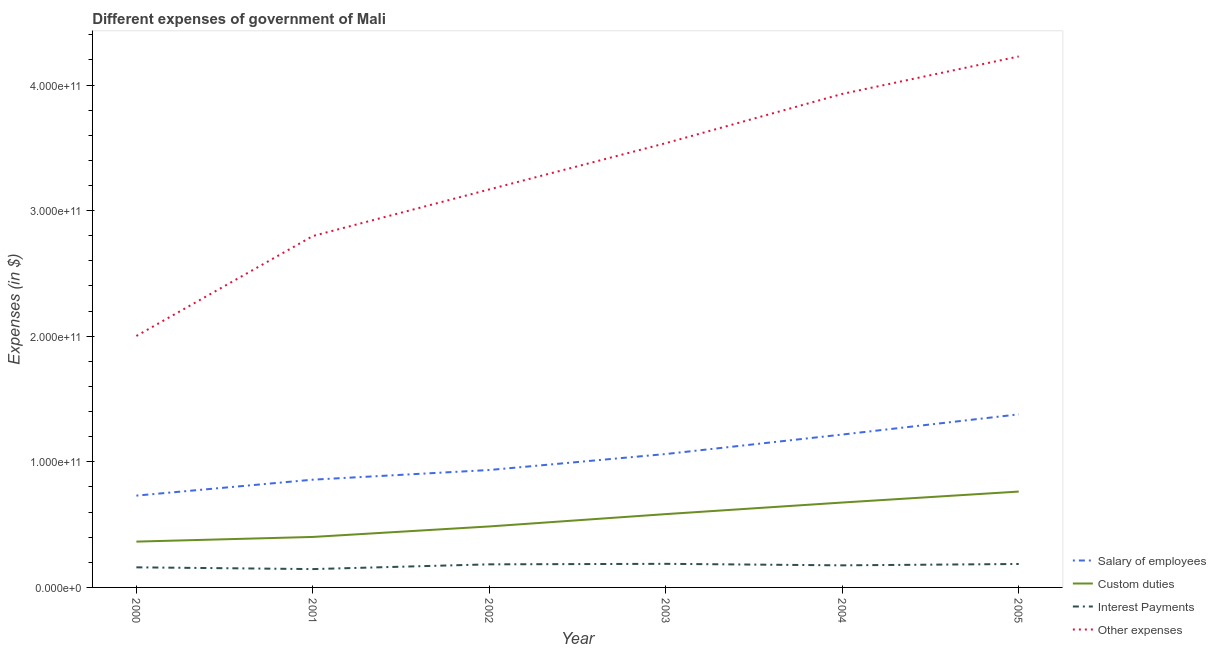Does the line corresponding to amount spent on other expenses intersect with the line corresponding to amount spent on salary of employees?
Your response must be concise. No. What is the amount spent on salary of employees in 2003?
Your answer should be compact. 1.06e+11. Across all years, what is the maximum amount spent on interest payments?
Provide a short and direct response. 1.88e+1. Across all years, what is the minimum amount spent on salary of employees?
Provide a succinct answer. 7.31e+1. In which year was the amount spent on interest payments minimum?
Your answer should be very brief. 2001. What is the total amount spent on interest payments in the graph?
Give a very brief answer. 1.04e+11. What is the difference between the amount spent on other expenses in 2004 and that in 2005?
Provide a succinct answer. -2.98e+1. What is the difference between the amount spent on interest payments in 2004 and the amount spent on custom duties in 2001?
Keep it short and to the point. -2.26e+1. What is the average amount spent on salary of employees per year?
Provide a short and direct response. 1.03e+11. In the year 2004, what is the difference between the amount spent on interest payments and amount spent on salary of employees?
Provide a short and direct response. -1.04e+11. In how many years, is the amount spent on custom duties greater than 220000000000 $?
Your answer should be compact. 0. What is the ratio of the amount spent on salary of employees in 2001 to that in 2004?
Provide a short and direct response. 0.7. Is the difference between the amount spent on custom duties in 2002 and 2003 greater than the difference between the amount spent on other expenses in 2002 and 2003?
Your answer should be very brief. Yes. What is the difference between the highest and the second highest amount spent on salary of employees?
Provide a short and direct response. 1.61e+1. What is the difference between the highest and the lowest amount spent on other expenses?
Your response must be concise. 2.23e+11. Is it the case that in every year, the sum of the amount spent on interest payments and amount spent on other expenses is greater than the sum of amount spent on salary of employees and amount spent on custom duties?
Keep it short and to the point. No. What is the difference between two consecutive major ticks on the Y-axis?
Your response must be concise. 1.00e+11. Does the graph contain grids?
Make the answer very short. No. How many legend labels are there?
Keep it short and to the point. 4. What is the title of the graph?
Offer a very short reply. Different expenses of government of Mali. Does "Secondary general" appear as one of the legend labels in the graph?
Provide a succinct answer. No. What is the label or title of the X-axis?
Provide a short and direct response. Year. What is the label or title of the Y-axis?
Keep it short and to the point. Expenses (in $). What is the Expenses (in $) of Salary of employees in 2000?
Provide a succinct answer. 7.31e+1. What is the Expenses (in $) of Custom duties in 2000?
Provide a short and direct response. 3.65e+1. What is the Expenses (in $) of Interest Payments in 2000?
Provide a succinct answer. 1.60e+1. What is the Expenses (in $) in Other expenses in 2000?
Provide a succinct answer. 2.00e+11. What is the Expenses (in $) of Salary of employees in 2001?
Offer a terse response. 8.58e+1. What is the Expenses (in $) in Custom duties in 2001?
Provide a short and direct response. 4.02e+1. What is the Expenses (in $) of Interest Payments in 2001?
Your answer should be compact. 1.46e+1. What is the Expenses (in $) of Other expenses in 2001?
Give a very brief answer. 2.80e+11. What is the Expenses (in $) of Salary of employees in 2002?
Ensure brevity in your answer.  9.35e+1. What is the Expenses (in $) in Custom duties in 2002?
Your answer should be very brief. 4.86e+1. What is the Expenses (in $) of Interest Payments in 2002?
Your answer should be very brief. 1.84e+1. What is the Expenses (in $) in Other expenses in 2002?
Your answer should be very brief. 3.17e+11. What is the Expenses (in $) in Salary of employees in 2003?
Provide a short and direct response. 1.06e+11. What is the Expenses (in $) of Custom duties in 2003?
Provide a succinct answer. 5.84e+1. What is the Expenses (in $) in Interest Payments in 2003?
Your answer should be very brief. 1.88e+1. What is the Expenses (in $) of Other expenses in 2003?
Offer a terse response. 3.54e+11. What is the Expenses (in $) in Salary of employees in 2004?
Your answer should be compact. 1.22e+11. What is the Expenses (in $) in Custom duties in 2004?
Your response must be concise. 6.76e+1. What is the Expenses (in $) of Interest Payments in 2004?
Your answer should be very brief. 1.76e+1. What is the Expenses (in $) in Other expenses in 2004?
Make the answer very short. 3.93e+11. What is the Expenses (in $) in Salary of employees in 2005?
Offer a terse response. 1.38e+11. What is the Expenses (in $) in Custom duties in 2005?
Your answer should be very brief. 7.63e+1. What is the Expenses (in $) of Interest Payments in 2005?
Your answer should be very brief. 1.87e+1. What is the Expenses (in $) of Other expenses in 2005?
Give a very brief answer. 4.23e+11. Across all years, what is the maximum Expenses (in $) in Salary of employees?
Ensure brevity in your answer.  1.38e+11. Across all years, what is the maximum Expenses (in $) of Custom duties?
Provide a short and direct response. 7.63e+1. Across all years, what is the maximum Expenses (in $) of Interest Payments?
Provide a succinct answer. 1.88e+1. Across all years, what is the maximum Expenses (in $) in Other expenses?
Provide a short and direct response. 4.23e+11. Across all years, what is the minimum Expenses (in $) of Salary of employees?
Keep it short and to the point. 7.31e+1. Across all years, what is the minimum Expenses (in $) of Custom duties?
Keep it short and to the point. 3.65e+1. Across all years, what is the minimum Expenses (in $) in Interest Payments?
Ensure brevity in your answer.  1.46e+1. Across all years, what is the minimum Expenses (in $) in Other expenses?
Offer a very short reply. 2.00e+11. What is the total Expenses (in $) of Salary of employees in the graph?
Provide a short and direct response. 6.18e+11. What is the total Expenses (in $) of Custom duties in the graph?
Provide a short and direct response. 3.28e+11. What is the total Expenses (in $) in Interest Payments in the graph?
Keep it short and to the point. 1.04e+11. What is the total Expenses (in $) of Other expenses in the graph?
Give a very brief answer. 1.97e+12. What is the difference between the Expenses (in $) in Salary of employees in 2000 and that in 2001?
Give a very brief answer. -1.27e+1. What is the difference between the Expenses (in $) of Custom duties in 2000 and that in 2001?
Provide a succinct answer. -3.72e+09. What is the difference between the Expenses (in $) of Interest Payments in 2000 and that in 2001?
Keep it short and to the point. 1.40e+09. What is the difference between the Expenses (in $) in Other expenses in 2000 and that in 2001?
Your response must be concise. -7.96e+1. What is the difference between the Expenses (in $) of Salary of employees in 2000 and that in 2002?
Keep it short and to the point. -2.04e+1. What is the difference between the Expenses (in $) of Custom duties in 2000 and that in 2002?
Offer a very short reply. -1.21e+1. What is the difference between the Expenses (in $) in Interest Payments in 2000 and that in 2002?
Give a very brief answer. -2.38e+09. What is the difference between the Expenses (in $) of Other expenses in 2000 and that in 2002?
Make the answer very short. -1.17e+11. What is the difference between the Expenses (in $) of Salary of employees in 2000 and that in 2003?
Keep it short and to the point. -3.31e+1. What is the difference between the Expenses (in $) in Custom duties in 2000 and that in 2003?
Offer a terse response. -2.19e+1. What is the difference between the Expenses (in $) of Interest Payments in 2000 and that in 2003?
Offer a very short reply. -2.79e+09. What is the difference between the Expenses (in $) of Other expenses in 2000 and that in 2003?
Provide a succinct answer. -1.54e+11. What is the difference between the Expenses (in $) in Salary of employees in 2000 and that in 2004?
Give a very brief answer. -4.86e+1. What is the difference between the Expenses (in $) of Custom duties in 2000 and that in 2004?
Offer a terse response. -3.11e+1. What is the difference between the Expenses (in $) of Interest Payments in 2000 and that in 2004?
Keep it short and to the point. -1.58e+09. What is the difference between the Expenses (in $) in Other expenses in 2000 and that in 2004?
Give a very brief answer. -1.93e+11. What is the difference between the Expenses (in $) in Salary of employees in 2000 and that in 2005?
Your answer should be very brief. -6.47e+1. What is the difference between the Expenses (in $) of Custom duties in 2000 and that in 2005?
Your answer should be compact. -3.98e+1. What is the difference between the Expenses (in $) in Interest Payments in 2000 and that in 2005?
Provide a succinct answer. -2.66e+09. What is the difference between the Expenses (in $) in Other expenses in 2000 and that in 2005?
Offer a very short reply. -2.23e+11. What is the difference between the Expenses (in $) of Salary of employees in 2001 and that in 2002?
Keep it short and to the point. -7.70e+09. What is the difference between the Expenses (in $) in Custom duties in 2001 and that in 2002?
Give a very brief answer. -8.35e+09. What is the difference between the Expenses (in $) of Interest Payments in 2001 and that in 2002?
Your answer should be very brief. -3.78e+09. What is the difference between the Expenses (in $) of Other expenses in 2001 and that in 2002?
Offer a terse response. -3.71e+1. What is the difference between the Expenses (in $) in Salary of employees in 2001 and that in 2003?
Give a very brief answer. -2.04e+1. What is the difference between the Expenses (in $) of Custom duties in 2001 and that in 2003?
Give a very brief answer. -1.82e+1. What is the difference between the Expenses (in $) of Interest Payments in 2001 and that in 2003?
Offer a terse response. -4.19e+09. What is the difference between the Expenses (in $) of Other expenses in 2001 and that in 2003?
Your answer should be compact. -7.39e+1. What is the difference between the Expenses (in $) in Salary of employees in 2001 and that in 2004?
Offer a very short reply. -3.59e+1. What is the difference between the Expenses (in $) in Custom duties in 2001 and that in 2004?
Offer a terse response. -2.74e+1. What is the difference between the Expenses (in $) of Interest Payments in 2001 and that in 2004?
Keep it short and to the point. -2.98e+09. What is the difference between the Expenses (in $) of Other expenses in 2001 and that in 2004?
Make the answer very short. -1.13e+11. What is the difference between the Expenses (in $) in Salary of employees in 2001 and that in 2005?
Give a very brief answer. -5.20e+1. What is the difference between the Expenses (in $) in Custom duties in 2001 and that in 2005?
Offer a terse response. -3.61e+1. What is the difference between the Expenses (in $) of Interest Payments in 2001 and that in 2005?
Your answer should be compact. -4.06e+09. What is the difference between the Expenses (in $) in Other expenses in 2001 and that in 2005?
Provide a succinct answer. -1.43e+11. What is the difference between the Expenses (in $) of Salary of employees in 2002 and that in 2003?
Make the answer very short. -1.27e+1. What is the difference between the Expenses (in $) in Custom duties in 2002 and that in 2003?
Ensure brevity in your answer.  -9.82e+09. What is the difference between the Expenses (in $) in Interest Payments in 2002 and that in 2003?
Offer a terse response. -4.08e+08. What is the difference between the Expenses (in $) of Other expenses in 2002 and that in 2003?
Keep it short and to the point. -3.68e+1. What is the difference between the Expenses (in $) of Salary of employees in 2002 and that in 2004?
Your answer should be very brief. -2.82e+1. What is the difference between the Expenses (in $) of Custom duties in 2002 and that in 2004?
Provide a succinct answer. -1.90e+1. What is the difference between the Expenses (in $) of Interest Payments in 2002 and that in 2004?
Ensure brevity in your answer.  8.02e+08. What is the difference between the Expenses (in $) of Other expenses in 2002 and that in 2004?
Provide a short and direct response. -7.60e+1. What is the difference between the Expenses (in $) in Salary of employees in 2002 and that in 2005?
Provide a succinct answer. -4.43e+1. What is the difference between the Expenses (in $) of Custom duties in 2002 and that in 2005?
Give a very brief answer. -2.78e+1. What is the difference between the Expenses (in $) of Interest Payments in 2002 and that in 2005?
Offer a very short reply. -2.80e+08. What is the difference between the Expenses (in $) of Other expenses in 2002 and that in 2005?
Provide a succinct answer. -1.06e+11. What is the difference between the Expenses (in $) of Salary of employees in 2003 and that in 2004?
Provide a succinct answer. -1.55e+1. What is the difference between the Expenses (in $) in Custom duties in 2003 and that in 2004?
Your answer should be very brief. -9.22e+09. What is the difference between the Expenses (in $) of Interest Payments in 2003 and that in 2004?
Offer a very short reply. 1.21e+09. What is the difference between the Expenses (in $) of Other expenses in 2003 and that in 2004?
Provide a succinct answer. -3.92e+1. What is the difference between the Expenses (in $) of Salary of employees in 2003 and that in 2005?
Provide a succinct answer. -3.16e+1. What is the difference between the Expenses (in $) in Custom duties in 2003 and that in 2005?
Your answer should be very brief. -1.79e+1. What is the difference between the Expenses (in $) of Interest Payments in 2003 and that in 2005?
Give a very brief answer. 1.27e+08. What is the difference between the Expenses (in $) of Other expenses in 2003 and that in 2005?
Your answer should be compact. -6.90e+1. What is the difference between the Expenses (in $) in Salary of employees in 2004 and that in 2005?
Provide a succinct answer. -1.61e+1. What is the difference between the Expenses (in $) of Custom duties in 2004 and that in 2005?
Ensure brevity in your answer.  -8.73e+09. What is the difference between the Expenses (in $) of Interest Payments in 2004 and that in 2005?
Your answer should be compact. -1.08e+09. What is the difference between the Expenses (in $) of Other expenses in 2004 and that in 2005?
Make the answer very short. -2.98e+1. What is the difference between the Expenses (in $) of Salary of employees in 2000 and the Expenses (in $) of Custom duties in 2001?
Offer a very short reply. 3.29e+1. What is the difference between the Expenses (in $) in Salary of employees in 2000 and the Expenses (in $) in Interest Payments in 2001?
Provide a succinct answer. 5.85e+1. What is the difference between the Expenses (in $) of Salary of employees in 2000 and the Expenses (in $) of Other expenses in 2001?
Your answer should be very brief. -2.07e+11. What is the difference between the Expenses (in $) of Custom duties in 2000 and the Expenses (in $) of Interest Payments in 2001?
Ensure brevity in your answer.  2.19e+1. What is the difference between the Expenses (in $) in Custom duties in 2000 and the Expenses (in $) in Other expenses in 2001?
Offer a very short reply. -2.43e+11. What is the difference between the Expenses (in $) of Interest Payments in 2000 and the Expenses (in $) of Other expenses in 2001?
Make the answer very short. -2.64e+11. What is the difference between the Expenses (in $) of Salary of employees in 2000 and the Expenses (in $) of Custom duties in 2002?
Make the answer very short. 2.45e+1. What is the difference between the Expenses (in $) of Salary of employees in 2000 and the Expenses (in $) of Interest Payments in 2002?
Your response must be concise. 5.47e+1. What is the difference between the Expenses (in $) in Salary of employees in 2000 and the Expenses (in $) in Other expenses in 2002?
Your answer should be very brief. -2.44e+11. What is the difference between the Expenses (in $) in Custom duties in 2000 and the Expenses (in $) in Interest Payments in 2002?
Offer a terse response. 1.81e+1. What is the difference between the Expenses (in $) in Custom duties in 2000 and the Expenses (in $) in Other expenses in 2002?
Provide a succinct answer. -2.80e+11. What is the difference between the Expenses (in $) in Interest Payments in 2000 and the Expenses (in $) in Other expenses in 2002?
Your response must be concise. -3.01e+11. What is the difference between the Expenses (in $) in Salary of employees in 2000 and the Expenses (in $) in Custom duties in 2003?
Provide a short and direct response. 1.47e+1. What is the difference between the Expenses (in $) of Salary of employees in 2000 and the Expenses (in $) of Interest Payments in 2003?
Give a very brief answer. 5.43e+1. What is the difference between the Expenses (in $) of Salary of employees in 2000 and the Expenses (in $) of Other expenses in 2003?
Provide a short and direct response. -2.81e+11. What is the difference between the Expenses (in $) of Custom duties in 2000 and the Expenses (in $) of Interest Payments in 2003?
Give a very brief answer. 1.77e+1. What is the difference between the Expenses (in $) in Custom duties in 2000 and the Expenses (in $) in Other expenses in 2003?
Keep it short and to the point. -3.17e+11. What is the difference between the Expenses (in $) of Interest Payments in 2000 and the Expenses (in $) of Other expenses in 2003?
Provide a short and direct response. -3.38e+11. What is the difference between the Expenses (in $) of Salary of employees in 2000 and the Expenses (in $) of Custom duties in 2004?
Ensure brevity in your answer.  5.51e+09. What is the difference between the Expenses (in $) in Salary of employees in 2000 and the Expenses (in $) in Interest Payments in 2004?
Make the answer very short. 5.55e+1. What is the difference between the Expenses (in $) in Salary of employees in 2000 and the Expenses (in $) in Other expenses in 2004?
Provide a short and direct response. -3.20e+11. What is the difference between the Expenses (in $) in Custom duties in 2000 and the Expenses (in $) in Interest Payments in 2004?
Keep it short and to the point. 1.89e+1. What is the difference between the Expenses (in $) of Custom duties in 2000 and the Expenses (in $) of Other expenses in 2004?
Keep it short and to the point. -3.56e+11. What is the difference between the Expenses (in $) of Interest Payments in 2000 and the Expenses (in $) of Other expenses in 2004?
Provide a short and direct response. -3.77e+11. What is the difference between the Expenses (in $) in Salary of employees in 2000 and the Expenses (in $) in Custom duties in 2005?
Make the answer very short. -3.22e+09. What is the difference between the Expenses (in $) of Salary of employees in 2000 and the Expenses (in $) of Interest Payments in 2005?
Provide a short and direct response. 5.44e+1. What is the difference between the Expenses (in $) in Salary of employees in 2000 and the Expenses (in $) in Other expenses in 2005?
Give a very brief answer. -3.50e+11. What is the difference between the Expenses (in $) in Custom duties in 2000 and the Expenses (in $) in Interest Payments in 2005?
Your answer should be very brief. 1.78e+1. What is the difference between the Expenses (in $) in Custom duties in 2000 and the Expenses (in $) in Other expenses in 2005?
Offer a very short reply. -3.86e+11. What is the difference between the Expenses (in $) in Interest Payments in 2000 and the Expenses (in $) in Other expenses in 2005?
Your answer should be compact. -4.07e+11. What is the difference between the Expenses (in $) of Salary of employees in 2001 and the Expenses (in $) of Custom duties in 2002?
Your answer should be very brief. 3.72e+1. What is the difference between the Expenses (in $) in Salary of employees in 2001 and the Expenses (in $) in Interest Payments in 2002?
Your answer should be compact. 6.74e+1. What is the difference between the Expenses (in $) of Salary of employees in 2001 and the Expenses (in $) of Other expenses in 2002?
Offer a very short reply. -2.31e+11. What is the difference between the Expenses (in $) of Custom duties in 2001 and the Expenses (in $) of Interest Payments in 2002?
Your answer should be compact. 2.18e+1. What is the difference between the Expenses (in $) in Custom duties in 2001 and the Expenses (in $) in Other expenses in 2002?
Your answer should be very brief. -2.77e+11. What is the difference between the Expenses (in $) in Interest Payments in 2001 and the Expenses (in $) in Other expenses in 2002?
Keep it short and to the point. -3.02e+11. What is the difference between the Expenses (in $) in Salary of employees in 2001 and the Expenses (in $) in Custom duties in 2003?
Give a very brief answer. 2.74e+1. What is the difference between the Expenses (in $) of Salary of employees in 2001 and the Expenses (in $) of Interest Payments in 2003?
Make the answer very short. 6.70e+1. What is the difference between the Expenses (in $) in Salary of employees in 2001 and the Expenses (in $) in Other expenses in 2003?
Your answer should be compact. -2.68e+11. What is the difference between the Expenses (in $) of Custom duties in 2001 and the Expenses (in $) of Interest Payments in 2003?
Offer a very short reply. 2.14e+1. What is the difference between the Expenses (in $) of Custom duties in 2001 and the Expenses (in $) of Other expenses in 2003?
Offer a terse response. -3.14e+11. What is the difference between the Expenses (in $) of Interest Payments in 2001 and the Expenses (in $) of Other expenses in 2003?
Your answer should be very brief. -3.39e+11. What is the difference between the Expenses (in $) of Salary of employees in 2001 and the Expenses (in $) of Custom duties in 2004?
Offer a very short reply. 1.82e+1. What is the difference between the Expenses (in $) in Salary of employees in 2001 and the Expenses (in $) in Interest Payments in 2004?
Your answer should be very brief. 6.82e+1. What is the difference between the Expenses (in $) of Salary of employees in 2001 and the Expenses (in $) of Other expenses in 2004?
Your answer should be compact. -3.07e+11. What is the difference between the Expenses (in $) of Custom duties in 2001 and the Expenses (in $) of Interest Payments in 2004?
Make the answer very short. 2.26e+1. What is the difference between the Expenses (in $) in Custom duties in 2001 and the Expenses (in $) in Other expenses in 2004?
Give a very brief answer. -3.53e+11. What is the difference between the Expenses (in $) in Interest Payments in 2001 and the Expenses (in $) in Other expenses in 2004?
Ensure brevity in your answer.  -3.78e+11. What is the difference between the Expenses (in $) in Salary of employees in 2001 and the Expenses (in $) in Custom duties in 2005?
Your response must be concise. 9.47e+09. What is the difference between the Expenses (in $) in Salary of employees in 2001 and the Expenses (in $) in Interest Payments in 2005?
Offer a terse response. 6.71e+1. What is the difference between the Expenses (in $) of Salary of employees in 2001 and the Expenses (in $) of Other expenses in 2005?
Your response must be concise. -3.37e+11. What is the difference between the Expenses (in $) of Custom duties in 2001 and the Expenses (in $) of Interest Payments in 2005?
Offer a terse response. 2.15e+1. What is the difference between the Expenses (in $) of Custom duties in 2001 and the Expenses (in $) of Other expenses in 2005?
Your answer should be very brief. -3.83e+11. What is the difference between the Expenses (in $) of Interest Payments in 2001 and the Expenses (in $) of Other expenses in 2005?
Your response must be concise. -4.08e+11. What is the difference between the Expenses (in $) in Salary of employees in 2002 and the Expenses (in $) in Custom duties in 2003?
Keep it short and to the point. 3.51e+1. What is the difference between the Expenses (in $) of Salary of employees in 2002 and the Expenses (in $) of Interest Payments in 2003?
Make the answer very short. 7.47e+1. What is the difference between the Expenses (in $) of Salary of employees in 2002 and the Expenses (in $) of Other expenses in 2003?
Keep it short and to the point. -2.60e+11. What is the difference between the Expenses (in $) of Custom duties in 2002 and the Expenses (in $) of Interest Payments in 2003?
Your answer should be very brief. 2.98e+1. What is the difference between the Expenses (in $) of Custom duties in 2002 and the Expenses (in $) of Other expenses in 2003?
Your answer should be very brief. -3.05e+11. What is the difference between the Expenses (in $) of Interest Payments in 2002 and the Expenses (in $) of Other expenses in 2003?
Your response must be concise. -3.35e+11. What is the difference between the Expenses (in $) in Salary of employees in 2002 and the Expenses (in $) in Custom duties in 2004?
Keep it short and to the point. 2.59e+1. What is the difference between the Expenses (in $) of Salary of employees in 2002 and the Expenses (in $) of Interest Payments in 2004?
Ensure brevity in your answer.  7.59e+1. What is the difference between the Expenses (in $) of Salary of employees in 2002 and the Expenses (in $) of Other expenses in 2004?
Offer a very short reply. -2.99e+11. What is the difference between the Expenses (in $) in Custom duties in 2002 and the Expenses (in $) in Interest Payments in 2004?
Your answer should be compact. 3.10e+1. What is the difference between the Expenses (in $) of Custom duties in 2002 and the Expenses (in $) of Other expenses in 2004?
Your answer should be compact. -3.44e+11. What is the difference between the Expenses (in $) in Interest Payments in 2002 and the Expenses (in $) in Other expenses in 2004?
Your answer should be compact. -3.75e+11. What is the difference between the Expenses (in $) of Salary of employees in 2002 and the Expenses (in $) of Custom duties in 2005?
Offer a very short reply. 1.72e+1. What is the difference between the Expenses (in $) in Salary of employees in 2002 and the Expenses (in $) in Interest Payments in 2005?
Your response must be concise. 7.48e+1. What is the difference between the Expenses (in $) of Salary of employees in 2002 and the Expenses (in $) of Other expenses in 2005?
Provide a short and direct response. -3.29e+11. What is the difference between the Expenses (in $) of Custom duties in 2002 and the Expenses (in $) of Interest Payments in 2005?
Your answer should be compact. 2.99e+1. What is the difference between the Expenses (in $) in Custom duties in 2002 and the Expenses (in $) in Other expenses in 2005?
Make the answer very short. -3.74e+11. What is the difference between the Expenses (in $) of Interest Payments in 2002 and the Expenses (in $) of Other expenses in 2005?
Your response must be concise. -4.04e+11. What is the difference between the Expenses (in $) in Salary of employees in 2003 and the Expenses (in $) in Custom duties in 2004?
Your response must be concise. 3.86e+1. What is the difference between the Expenses (in $) in Salary of employees in 2003 and the Expenses (in $) in Interest Payments in 2004?
Offer a very short reply. 8.86e+1. What is the difference between the Expenses (in $) of Salary of employees in 2003 and the Expenses (in $) of Other expenses in 2004?
Give a very brief answer. -2.87e+11. What is the difference between the Expenses (in $) of Custom duties in 2003 and the Expenses (in $) of Interest Payments in 2004?
Provide a succinct answer. 4.08e+1. What is the difference between the Expenses (in $) in Custom duties in 2003 and the Expenses (in $) in Other expenses in 2004?
Offer a very short reply. -3.35e+11. What is the difference between the Expenses (in $) in Interest Payments in 2003 and the Expenses (in $) in Other expenses in 2004?
Your answer should be very brief. -3.74e+11. What is the difference between the Expenses (in $) in Salary of employees in 2003 and the Expenses (in $) in Custom duties in 2005?
Give a very brief answer. 2.99e+1. What is the difference between the Expenses (in $) in Salary of employees in 2003 and the Expenses (in $) in Interest Payments in 2005?
Provide a short and direct response. 8.75e+1. What is the difference between the Expenses (in $) in Salary of employees in 2003 and the Expenses (in $) in Other expenses in 2005?
Keep it short and to the point. -3.17e+11. What is the difference between the Expenses (in $) of Custom duties in 2003 and the Expenses (in $) of Interest Payments in 2005?
Your answer should be very brief. 3.97e+1. What is the difference between the Expenses (in $) in Custom duties in 2003 and the Expenses (in $) in Other expenses in 2005?
Offer a very short reply. -3.64e+11. What is the difference between the Expenses (in $) in Interest Payments in 2003 and the Expenses (in $) in Other expenses in 2005?
Offer a terse response. -4.04e+11. What is the difference between the Expenses (in $) in Salary of employees in 2004 and the Expenses (in $) in Custom duties in 2005?
Your answer should be very brief. 4.54e+1. What is the difference between the Expenses (in $) of Salary of employees in 2004 and the Expenses (in $) of Interest Payments in 2005?
Offer a terse response. 1.03e+11. What is the difference between the Expenses (in $) in Salary of employees in 2004 and the Expenses (in $) in Other expenses in 2005?
Provide a short and direct response. -3.01e+11. What is the difference between the Expenses (in $) of Custom duties in 2004 and the Expenses (in $) of Interest Payments in 2005?
Your answer should be very brief. 4.89e+1. What is the difference between the Expenses (in $) of Custom duties in 2004 and the Expenses (in $) of Other expenses in 2005?
Ensure brevity in your answer.  -3.55e+11. What is the difference between the Expenses (in $) of Interest Payments in 2004 and the Expenses (in $) of Other expenses in 2005?
Keep it short and to the point. -4.05e+11. What is the average Expenses (in $) in Salary of employees per year?
Ensure brevity in your answer.  1.03e+11. What is the average Expenses (in $) of Custom duties per year?
Your answer should be very brief. 5.46e+1. What is the average Expenses (in $) in Interest Payments per year?
Offer a terse response. 1.73e+1. What is the average Expenses (in $) in Other expenses per year?
Your answer should be compact. 3.28e+11. In the year 2000, what is the difference between the Expenses (in $) of Salary of employees and Expenses (in $) of Custom duties?
Your answer should be compact. 3.66e+1. In the year 2000, what is the difference between the Expenses (in $) of Salary of employees and Expenses (in $) of Interest Payments?
Provide a succinct answer. 5.71e+1. In the year 2000, what is the difference between the Expenses (in $) of Salary of employees and Expenses (in $) of Other expenses?
Provide a succinct answer. -1.27e+11. In the year 2000, what is the difference between the Expenses (in $) in Custom duties and Expenses (in $) in Interest Payments?
Offer a very short reply. 2.05e+1. In the year 2000, what is the difference between the Expenses (in $) in Custom duties and Expenses (in $) in Other expenses?
Your answer should be compact. -1.64e+11. In the year 2000, what is the difference between the Expenses (in $) of Interest Payments and Expenses (in $) of Other expenses?
Provide a succinct answer. -1.84e+11. In the year 2001, what is the difference between the Expenses (in $) in Salary of employees and Expenses (in $) in Custom duties?
Give a very brief answer. 4.56e+1. In the year 2001, what is the difference between the Expenses (in $) of Salary of employees and Expenses (in $) of Interest Payments?
Ensure brevity in your answer.  7.12e+1. In the year 2001, what is the difference between the Expenses (in $) in Salary of employees and Expenses (in $) in Other expenses?
Your answer should be very brief. -1.94e+11. In the year 2001, what is the difference between the Expenses (in $) of Custom duties and Expenses (in $) of Interest Payments?
Ensure brevity in your answer.  2.56e+1. In the year 2001, what is the difference between the Expenses (in $) in Custom duties and Expenses (in $) in Other expenses?
Offer a very short reply. -2.40e+11. In the year 2001, what is the difference between the Expenses (in $) of Interest Payments and Expenses (in $) of Other expenses?
Your answer should be very brief. -2.65e+11. In the year 2002, what is the difference between the Expenses (in $) of Salary of employees and Expenses (in $) of Custom duties?
Offer a terse response. 4.49e+1. In the year 2002, what is the difference between the Expenses (in $) in Salary of employees and Expenses (in $) in Interest Payments?
Ensure brevity in your answer.  7.51e+1. In the year 2002, what is the difference between the Expenses (in $) of Salary of employees and Expenses (in $) of Other expenses?
Ensure brevity in your answer.  -2.23e+11. In the year 2002, what is the difference between the Expenses (in $) of Custom duties and Expenses (in $) of Interest Payments?
Keep it short and to the point. 3.02e+1. In the year 2002, what is the difference between the Expenses (in $) in Custom duties and Expenses (in $) in Other expenses?
Give a very brief answer. -2.68e+11. In the year 2002, what is the difference between the Expenses (in $) in Interest Payments and Expenses (in $) in Other expenses?
Keep it short and to the point. -2.99e+11. In the year 2003, what is the difference between the Expenses (in $) in Salary of employees and Expenses (in $) in Custom duties?
Offer a terse response. 4.78e+1. In the year 2003, what is the difference between the Expenses (in $) of Salary of employees and Expenses (in $) of Interest Payments?
Offer a terse response. 8.74e+1. In the year 2003, what is the difference between the Expenses (in $) of Salary of employees and Expenses (in $) of Other expenses?
Keep it short and to the point. -2.47e+11. In the year 2003, what is the difference between the Expenses (in $) of Custom duties and Expenses (in $) of Interest Payments?
Offer a very short reply. 3.96e+1. In the year 2003, what is the difference between the Expenses (in $) in Custom duties and Expenses (in $) in Other expenses?
Offer a terse response. -2.95e+11. In the year 2003, what is the difference between the Expenses (in $) in Interest Payments and Expenses (in $) in Other expenses?
Keep it short and to the point. -3.35e+11. In the year 2004, what is the difference between the Expenses (in $) of Salary of employees and Expenses (in $) of Custom duties?
Keep it short and to the point. 5.41e+1. In the year 2004, what is the difference between the Expenses (in $) of Salary of employees and Expenses (in $) of Interest Payments?
Ensure brevity in your answer.  1.04e+11. In the year 2004, what is the difference between the Expenses (in $) in Salary of employees and Expenses (in $) in Other expenses?
Offer a terse response. -2.71e+11. In the year 2004, what is the difference between the Expenses (in $) of Custom duties and Expenses (in $) of Interest Payments?
Make the answer very short. 5.00e+1. In the year 2004, what is the difference between the Expenses (in $) in Custom duties and Expenses (in $) in Other expenses?
Make the answer very short. -3.25e+11. In the year 2004, what is the difference between the Expenses (in $) in Interest Payments and Expenses (in $) in Other expenses?
Offer a terse response. -3.75e+11. In the year 2005, what is the difference between the Expenses (in $) of Salary of employees and Expenses (in $) of Custom duties?
Provide a succinct answer. 6.15e+1. In the year 2005, what is the difference between the Expenses (in $) of Salary of employees and Expenses (in $) of Interest Payments?
Keep it short and to the point. 1.19e+11. In the year 2005, what is the difference between the Expenses (in $) in Salary of employees and Expenses (in $) in Other expenses?
Your answer should be very brief. -2.85e+11. In the year 2005, what is the difference between the Expenses (in $) of Custom duties and Expenses (in $) of Interest Payments?
Offer a terse response. 5.77e+1. In the year 2005, what is the difference between the Expenses (in $) of Custom duties and Expenses (in $) of Other expenses?
Give a very brief answer. -3.46e+11. In the year 2005, what is the difference between the Expenses (in $) in Interest Payments and Expenses (in $) in Other expenses?
Offer a very short reply. -4.04e+11. What is the ratio of the Expenses (in $) of Salary of employees in 2000 to that in 2001?
Keep it short and to the point. 0.85. What is the ratio of the Expenses (in $) in Custom duties in 2000 to that in 2001?
Your response must be concise. 0.91. What is the ratio of the Expenses (in $) of Interest Payments in 2000 to that in 2001?
Provide a short and direct response. 1.1. What is the ratio of the Expenses (in $) in Other expenses in 2000 to that in 2001?
Keep it short and to the point. 0.72. What is the ratio of the Expenses (in $) of Salary of employees in 2000 to that in 2002?
Give a very brief answer. 0.78. What is the ratio of the Expenses (in $) of Custom duties in 2000 to that in 2002?
Ensure brevity in your answer.  0.75. What is the ratio of the Expenses (in $) in Interest Payments in 2000 to that in 2002?
Your answer should be very brief. 0.87. What is the ratio of the Expenses (in $) of Other expenses in 2000 to that in 2002?
Ensure brevity in your answer.  0.63. What is the ratio of the Expenses (in $) of Salary of employees in 2000 to that in 2003?
Offer a very short reply. 0.69. What is the ratio of the Expenses (in $) in Custom duties in 2000 to that in 2003?
Offer a very short reply. 0.62. What is the ratio of the Expenses (in $) of Interest Payments in 2000 to that in 2003?
Provide a succinct answer. 0.85. What is the ratio of the Expenses (in $) in Other expenses in 2000 to that in 2003?
Keep it short and to the point. 0.57. What is the ratio of the Expenses (in $) of Salary of employees in 2000 to that in 2004?
Provide a short and direct response. 0.6. What is the ratio of the Expenses (in $) of Custom duties in 2000 to that in 2004?
Your answer should be compact. 0.54. What is the ratio of the Expenses (in $) in Interest Payments in 2000 to that in 2004?
Your answer should be very brief. 0.91. What is the ratio of the Expenses (in $) in Other expenses in 2000 to that in 2004?
Offer a terse response. 0.51. What is the ratio of the Expenses (in $) of Salary of employees in 2000 to that in 2005?
Offer a terse response. 0.53. What is the ratio of the Expenses (in $) in Custom duties in 2000 to that in 2005?
Your response must be concise. 0.48. What is the ratio of the Expenses (in $) in Interest Payments in 2000 to that in 2005?
Make the answer very short. 0.86. What is the ratio of the Expenses (in $) in Other expenses in 2000 to that in 2005?
Provide a succinct answer. 0.47. What is the ratio of the Expenses (in $) of Salary of employees in 2001 to that in 2002?
Keep it short and to the point. 0.92. What is the ratio of the Expenses (in $) in Custom duties in 2001 to that in 2002?
Your response must be concise. 0.83. What is the ratio of the Expenses (in $) of Interest Payments in 2001 to that in 2002?
Offer a terse response. 0.79. What is the ratio of the Expenses (in $) in Other expenses in 2001 to that in 2002?
Ensure brevity in your answer.  0.88. What is the ratio of the Expenses (in $) of Salary of employees in 2001 to that in 2003?
Your response must be concise. 0.81. What is the ratio of the Expenses (in $) in Custom duties in 2001 to that in 2003?
Keep it short and to the point. 0.69. What is the ratio of the Expenses (in $) in Interest Payments in 2001 to that in 2003?
Your response must be concise. 0.78. What is the ratio of the Expenses (in $) in Other expenses in 2001 to that in 2003?
Your answer should be very brief. 0.79. What is the ratio of the Expenses (in $) in Salary of employees in 2001 to that in 2004?
Give a very brief answer. 0.7. What is the ratio of the Expenses (in $) in Custom duties in 2001 to that in 2004?
Your response must be concise. 0.59. What is the ratio of the Expenses (in $) in Interest Payments in 2001 to that in 2004?
Your response must be concise. 0.83. What is the ratio of the Expenses (in $) in Other expenses in 2001 to that in 2004?
Your response must be concise. 0.71. What is the ratio of the Expenses (in $) of Salary of employees in 2001 to that in 2005?
Provide a short and direct response. 0.62. What is the ratio of the Expenses (in $) in Custom duties in 2001 to that in 2005?
Provide a short and direct response. 0.53. What is the ratio of the Expenses (in $) of Interest Payments in 2001 to that in 2005?
Give a very brief answer. 0.78. What is the ratio of the Expenses (in $) in Other expenses in 2001 to that in 2005?
Your answer should be very brief. 0.66. What is the ratio of the Expenses (in $) of Salary of employees in 2002 to that in 2003?
Your answer should be compact. 0.88. What is the ratio of the Expenses (in $) of Custom duties in 2002 to that in 2003?
Make the answer very short. 0.83. What is the ratio of the Expenses (in $) in Interest Payments in 2002 to that in 2003?
Provide a succinct answer. 0.98. What is the ratio of the Expenses (in $) of Other expenses in 2002 to that in 2003?
Your answer should be compact. 0.9. What is the ratio of the Expenses (in $) of Salary of employees in 2002 to that in 2004?
Offer a very short reply. 0.77. What is the ratio of the Expenses (in $) of Custom duties in 2002 to that in 2004?
Make the answer very short. 0.72. What is the ratio of the Expenses (in $) in Interest Payments in 2002 to that in 2004?
Provide a short and direct response. 1.05. What is the ratio of the Expenses (in $) of Other expenses in 2002 to that in 2004?
Ensure brevity in your answer.  0.81. What is the ratio of the Expenses (in $) in Salary of employees in 2002 to that in 2005?
Give a very brief answer. 0.68. What is the ratio of the Expenses (in $) of Custom duties in 2002 to that in 2005?
Offer a very short reply. 0.64. What is the ratio of the Expenses (in $) in Interest Payments in 2002 to that in 2005?
Ensure brevity in your answer.  0.98. What is the ratio of the Expenses (in $) in Other expenses in 2002 to that in 2005?
Your answer should be very brief. 0.75. What is the ratio of the Expenses (in $) of Salary of employees in 2003 to that in 2004?
Your answer should be very brief. 0.87. What is the ratio of the Expenses (in $) of Custom duties in 2003 to that in 2004?
Your answer should be very brief. 0.86. What is the ratio of the Expenses (in $) in Interest Payments in 2003 to that in 2004?
Your answer should be compact. 1.07. What is the ratio of the Expenses (in $) of Other expenses in 2003 to that in 2004?
Your answer should be compact. 0.9. What is the ratio of the Expenses (in $) in Salary of employees in 2003 to that in 2005?
Make the answer very short. 0.77. What is the ratio of the Expenses (in $) of Custom duties in 2003 to that in 2005?
Your answer should be very brief. 0.76. What is the ratio of the Expenses (in $) of Interest Payments in 2003 to that in 2005?
Your response must be concise. 1.01. What is the ratio of the Expenses (in $) of Other expenses in 2003 to that in 2005?
Offer a very short reply. 0.84. What is the ratio of the Expenses (in $) in Salary of employees in 2004 to that in 2005?
Offer a terse response. 0.88. What is the ratio of the Expenses (in $) in Custom duties in 2004 to that in 2005?
Ensure brevity in your answer.  0.89. What is the ratio of the Expenses (in $) in Interest Payments in 2004 to that in 2005?
Your response must be concise. 0.94. What is the ratio of the Expenses (in $) of Other expenses in 2004 to that in 2005?
Keep it short and to the point. 0.93. What is the difference between the highest and the second highest Expenses (in $) in Salary of employees?
Your response must be concise. 1.61e+1. What is the difference between the highest and the second highest Expenses (in $) of Custom duties?
Offer a terse response. 8.73e+09. What is the difference between the highest and the second highest Expenses (in $) in Interest Payments?
Provide a short and direct response. 1.27e+08. What is the difference between the highest and the second highest Expenses (in $) of Other expenses?
Make the answer very short. 2.98e+1. What is the difference between the highest and the lowest Expenses (in $) of Salary of employees?
Make the answer very short. 6.47e+1. What is the difference between the highest and the lowest Expenses (in $) in Custom duties?
Keep it short and to the point. 3.98e+1. What is the difference between the highest and the lowest Expenses (in $) in Interest Payments?
Keep it short and to the point. 4.19e+09. What is the difference between the highest and the lowest Expenses (in $) of Other expenses?
Offer a terse response. 2.23e+11. 